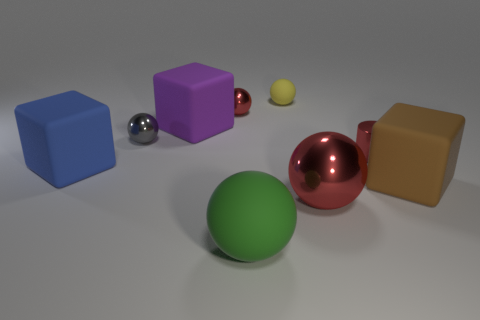Add 1 rubber cubes. How many objects exist? 10 Subtract all cyan balls. Subtract all green cylinders. How many balls are left? 5 Subtract all spheres. How many objects are left? 4 Add 6 metallic cylinders. How many metallic cylinders are left? 7 Add 9 tiny yellow cubes. How many tiny yellow cubes exist? 9 Subtract 0 brown balls. How many objects are left? 9 Subtract all cylinders. Subtract all tiny red shiny cylinders. How many objects are left? 7 